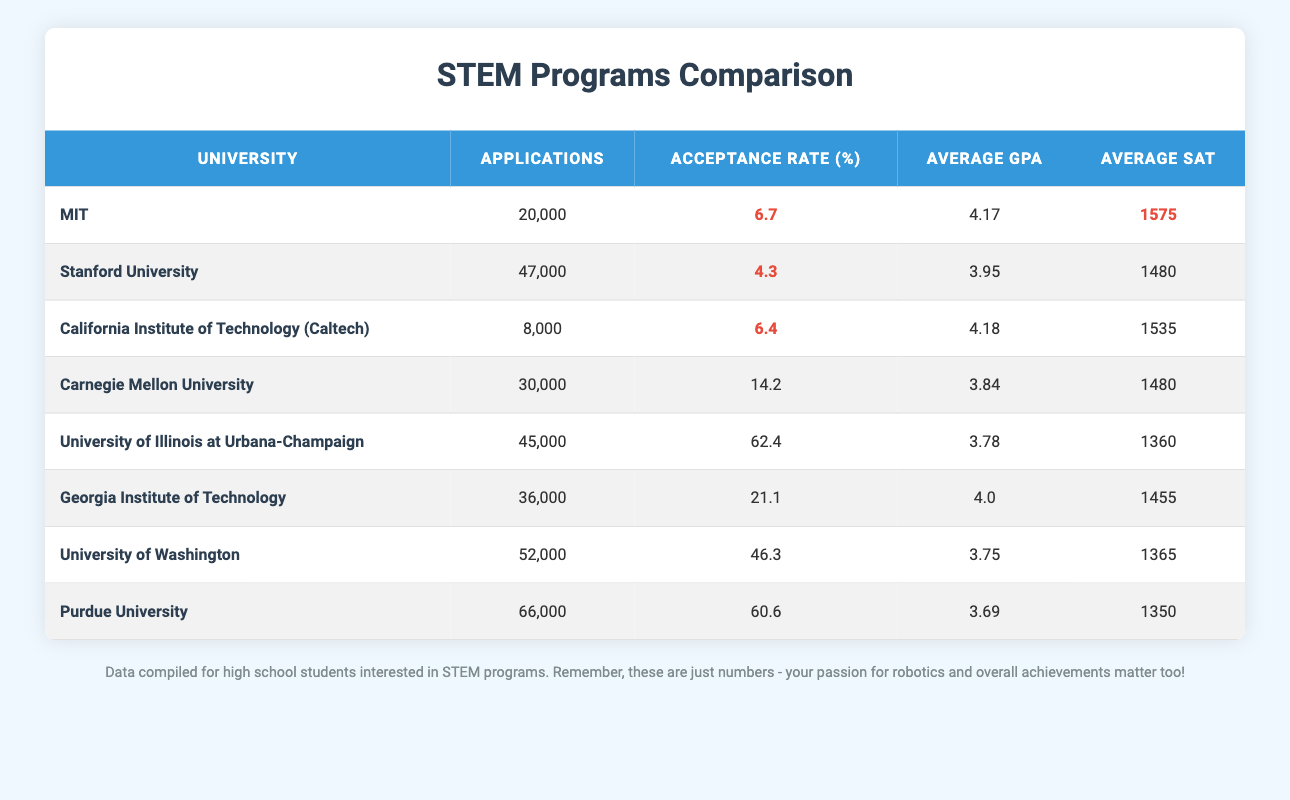What is the acceptance rate for Stanford University? The acceptance rate is listed in the table under the "Acceptance Rate (%)" column for Stanford University, which shows it as 4.3.
Answer: 4.3 Which university has the highest number of applications? The university with the highest number of applications can be found by comparing the "Applications" column. Purdue University has 66,000 applications, the highest among the listed universities.
Answer: Purdue University What is the average SAT score of the University of Illinois at Urbana-Champaign? The average SAT score is provided in the "Average SAT" column for the University of Illinois at Urbana-Champaign, which is 1360.
Answer: 1360 What is the difference in acceptance rates between Georgia Institute of Technology and the University of Washington? The acceptance rate for Georgia Institute of Technology is 21.1% and for the University of Washington is 46.3%. The difference can be calculated as 46.3 - 21.1 = 25.2%.
Answer: 25.2% Is the average GPA at Carnegie Mellon University higher than at the California Institute of Technology? The average GPA for Carnegie Mellon University is 3.84 and for California Institute of Technology is 4.18. Since 3.84 is less than 4.18, the statement is false.
Answer: No What is the total number of applications received by all universities listed? To find the total, we add all the applications from the "Applications" column: 20000 + 47000 + 8000 + 30000 + 45000 + 36000 + 52000 + 66000 = 235000.
Answer: 235000 Which university has the lowest average GPA among the listed schools? By reviewing the "Average GPA" column, Purdue University has the lowest average GPA of 3.69, compared to others in the table.
Answer: Purdue University If you were to find the average acceptance rate of the universities listed, what would it be? To calculate the average acceptance rate, we sum all the acceptance rates: 6.7 + 4.3 + 6.4 + 14.2 + 62.4 + 21.1 + 46.3 + 60.6 = 222.0. Then divide by the number of universities (8): 222.0 / 8 = 27.75%.
Answer: 27.75% 